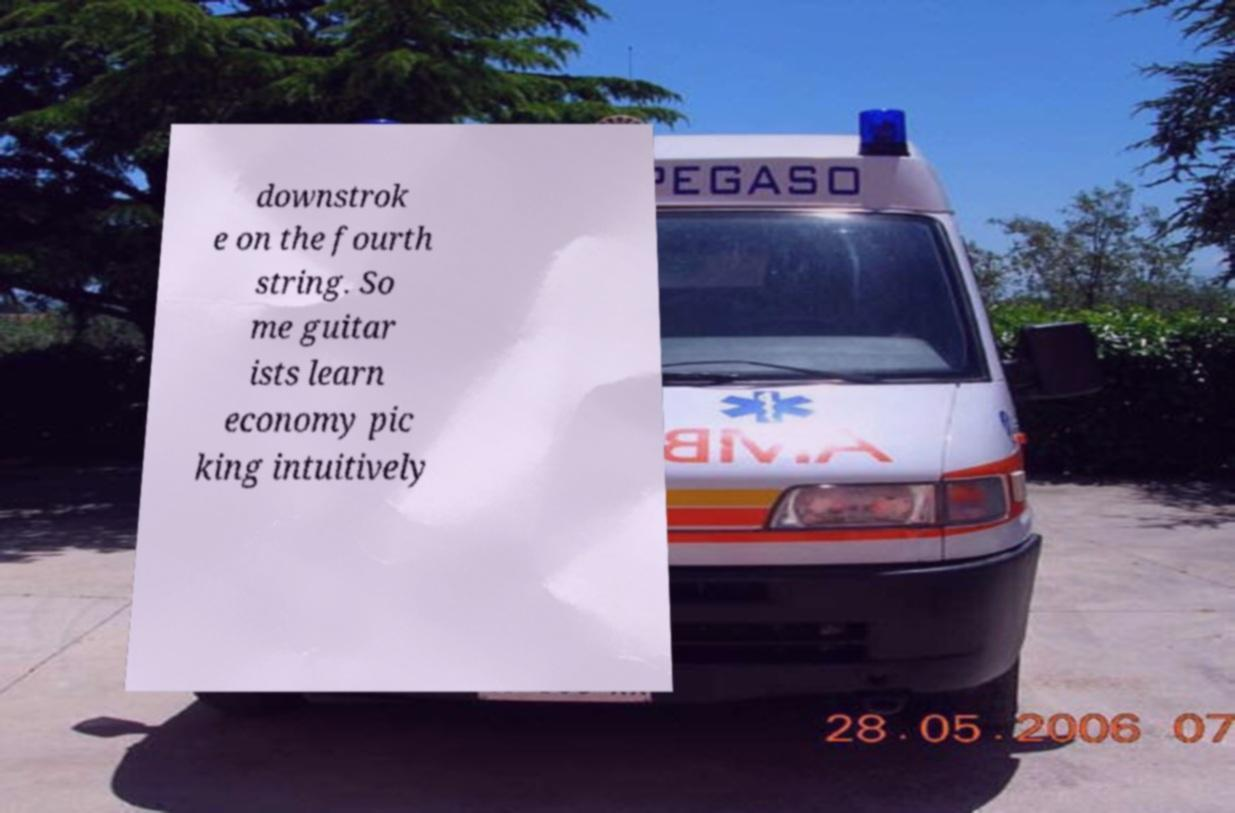There's text embedded in this image that I need extracted. Can you transcribe it verbatim? downstrok e on the fourth string. So me guitar ists learn economy pic king intuitively 